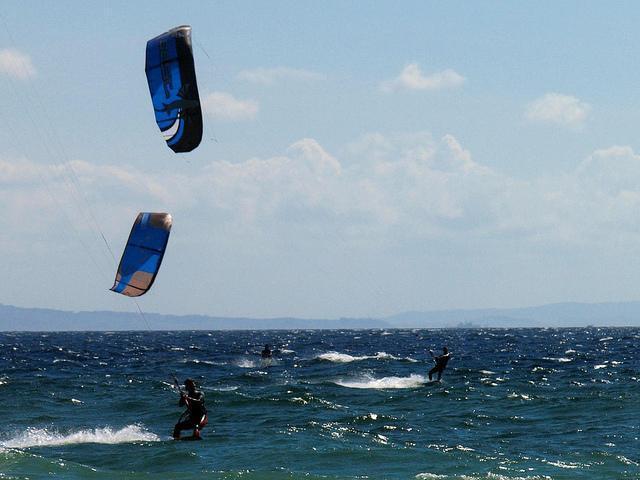How many people are in the water?
Give a very brief answer. 3. How many kites are in the photo?
Give a very brief answer. 2. 